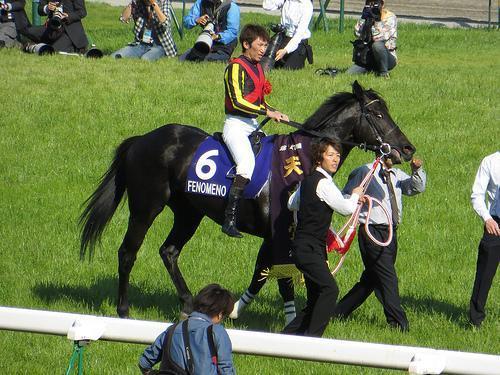How many horses are there?
Give a very brief answer. 1. How many white horses are there?
Give a very brief answer. 0. 